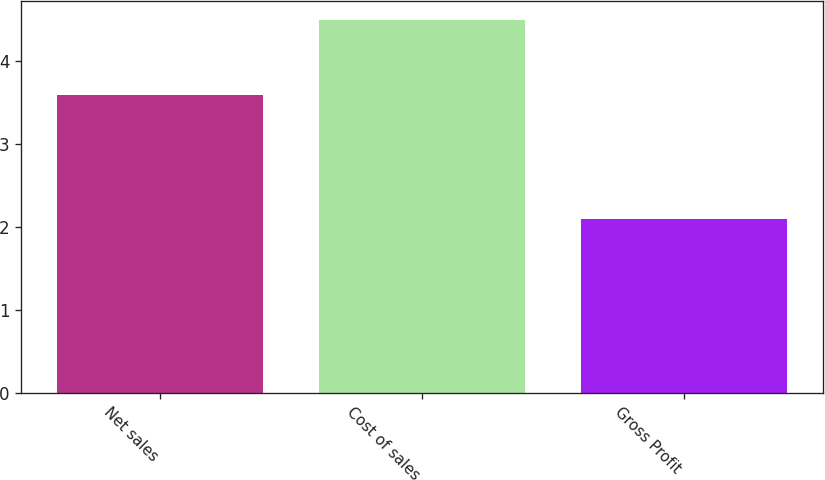Convert chart. <chart><loc_0><loc_0><loc_500><loc_500><bar_chart><fcel>Net sales<fcel>Cost of sales<fcel>Gross Profit<nl><fcel>3.6<fcel>4.5<fcel>2.1<nl></chart> 